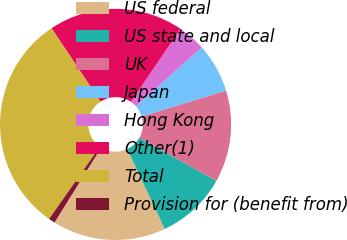Convert chart to OTSL. <chart><loc_0><loc_0><loc_500><loc_500><pie_chart><fcel>US federal<fcel>US state and local<fcel>UK<fcel>Japan<fcel>Hong Kong<fcel>Other(1)<fcel>Total<fcel>Provision for (benefit from)<nl><fcel>15.86%<fcel>9.87%<fcel>12.86%<fcel>6.88%<fcel>3.89%<fcel>18.85%<fcel>30.9%<fcel>0.9%<nl></chart> 